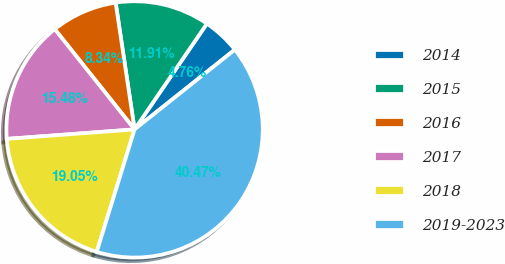Convert chart to OTSL. <chart><loc_0><loc_0><loc_500><loc_500><pie_chart><fcel>2014<fcel>2015<fcel>2016<fcel>2017<fcel>2018<fcel>2019-2023<nl><fcel>4.76%<fcel>11.91%<fcel>8.34%<fcel>15.48%<fcel>19.05%<fcel>40.47%<nl></chart> 